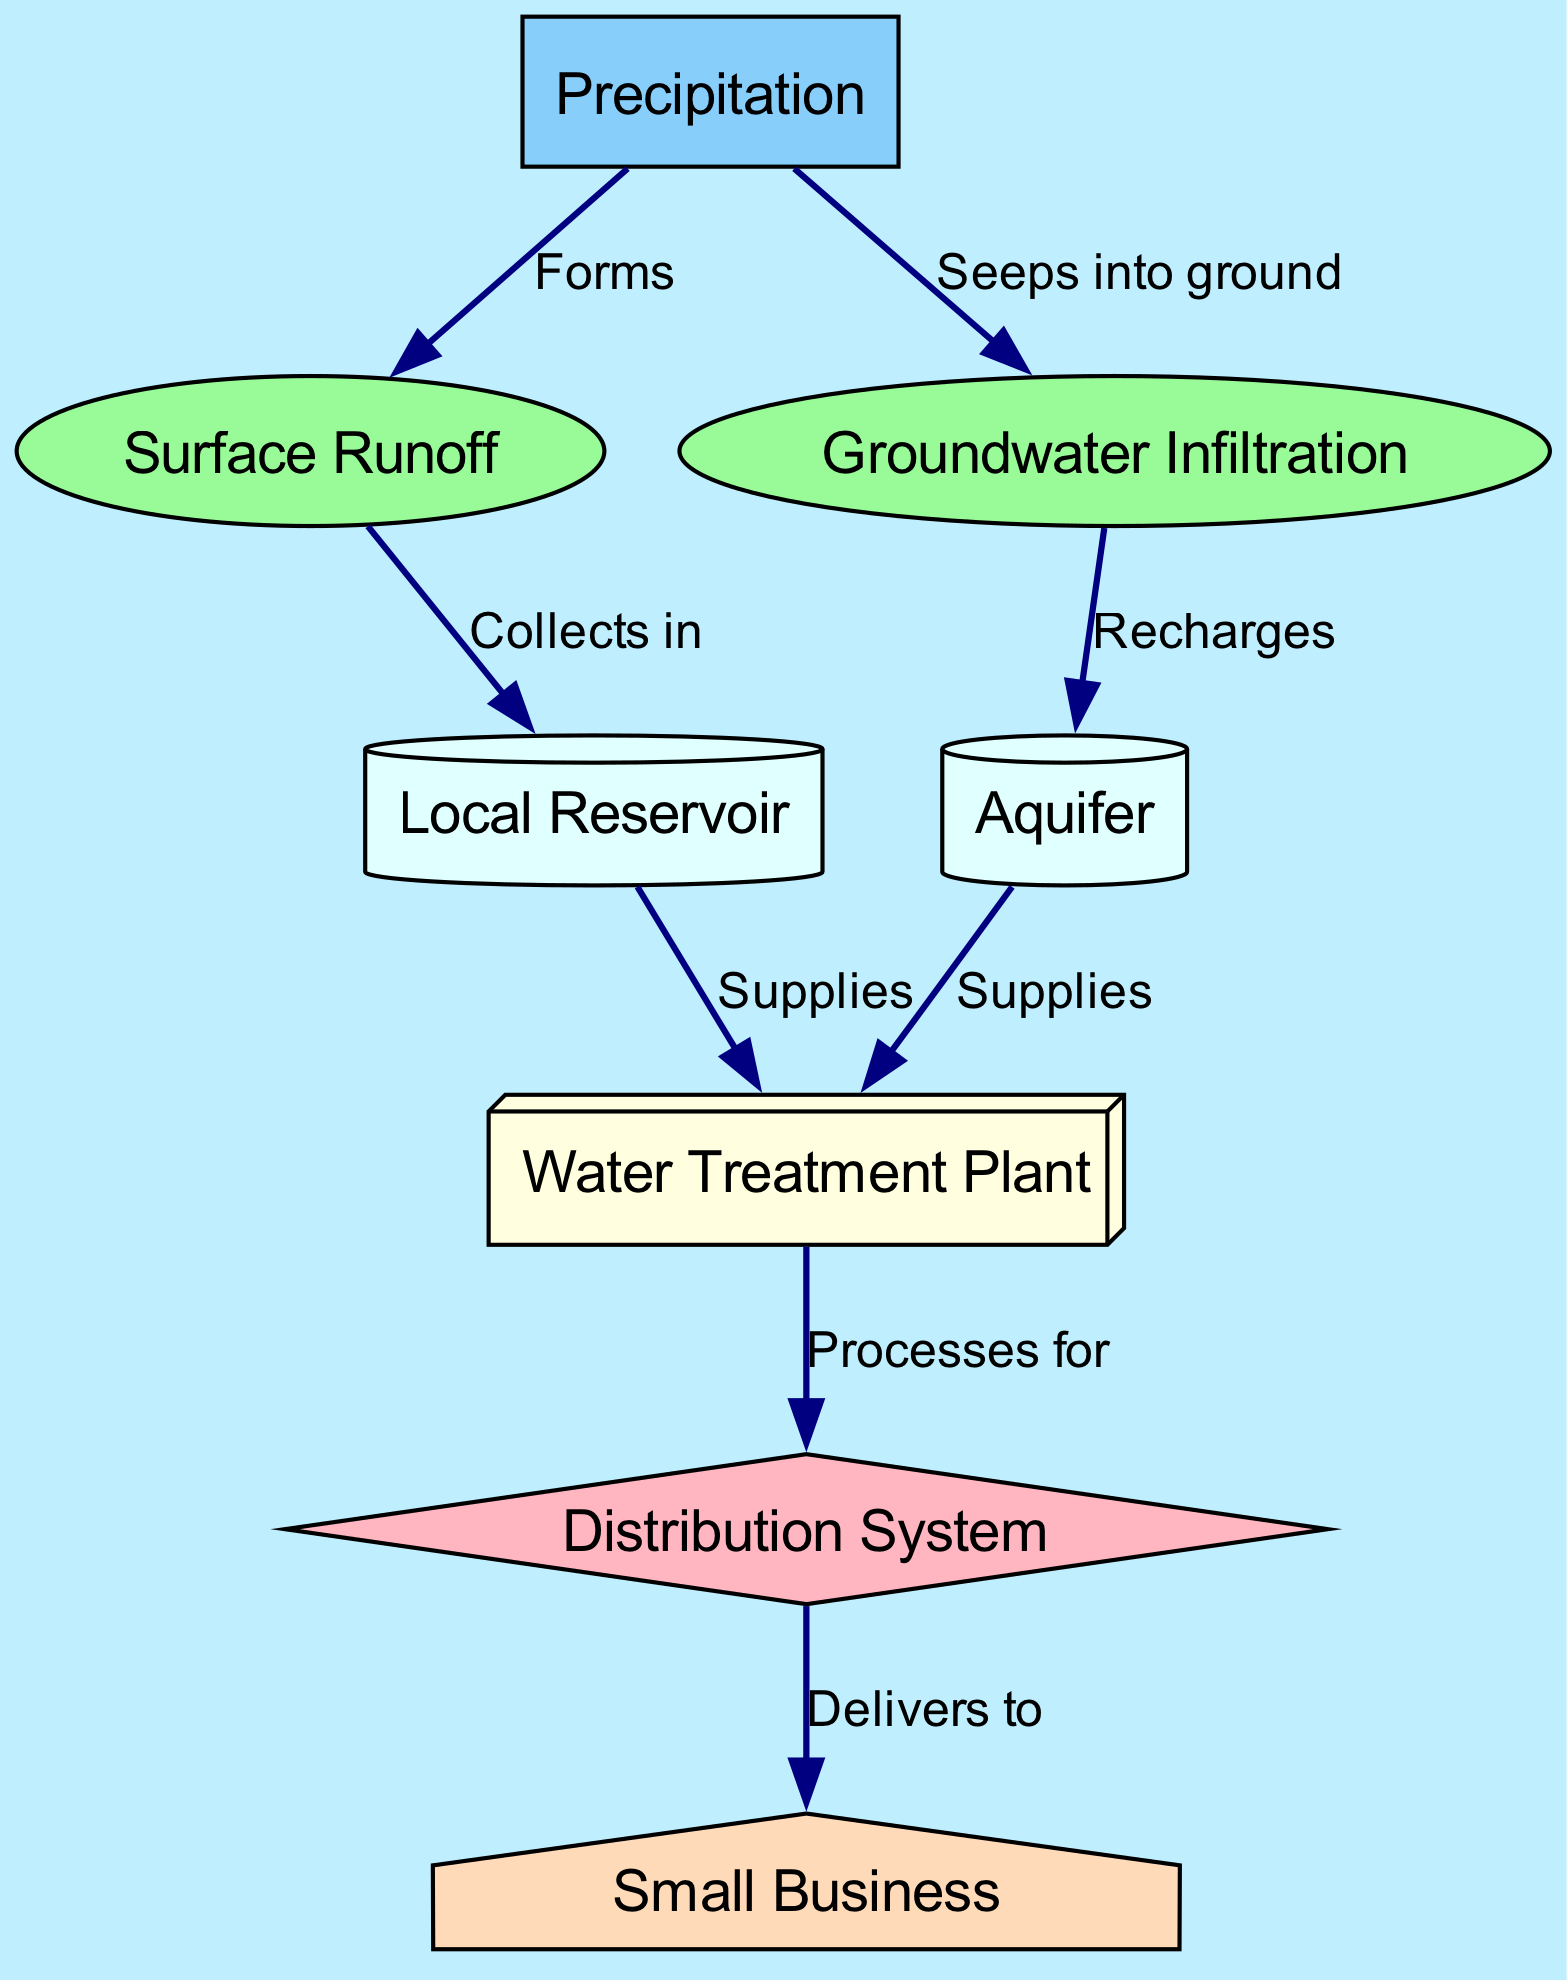What is the first step in the water cycle according to the diagram? The diagram indicates that 'Precipitation' is the first step, as it is the starting point of the water cycle.
Answer: Precipitation How many nodes are present in the diagram? By counting all the nodes listed in the data, we find that there are a total of eight nodes in the diagram.
Answer: Eight What does 'Surface Runoff' collect in? The connection from 'Surface Runoff' to 'Local Reservoir' shows that it collects water in the reservoir.
Answer: Local Reservoir How does the 'Aquifer' receive water? The diagram shows that the 'Aquifer' is recharged by 'Groundwater Infiltration' according to the directed edge between the nodes.
Answer: Recharges What processes water for distribution? 'Water Treatment Plant' is indicated as the node that processes water before it is distributed.
Answer: Water Treatment Plant What is delivered to 'Small Business' from the diagram? The diagram indicates that water is delivered to the 'Small Business' from the 'Distribution System.'
Answer: Distribution System How many edges are there in the diagram? By counting the relationships listed in the edges portion of the data, there are eight edges connecting the nodes.
Answer: Eight What role does 'Precipitation' play in the flow of water? 'Precipitation' serves as the source or starting point for both 'Surface Runoff' and 'Groundwater Infiltration', indicating its role in initiating the water cycle.
Answer: Forms What is the outcome for 'Local Reservoir' after collecting runoff? After collecting runoff, the 'Local Reservoir' supplies the 'Water Treatment Plant', indicating the forward flow of water.
Answer: Supplies 